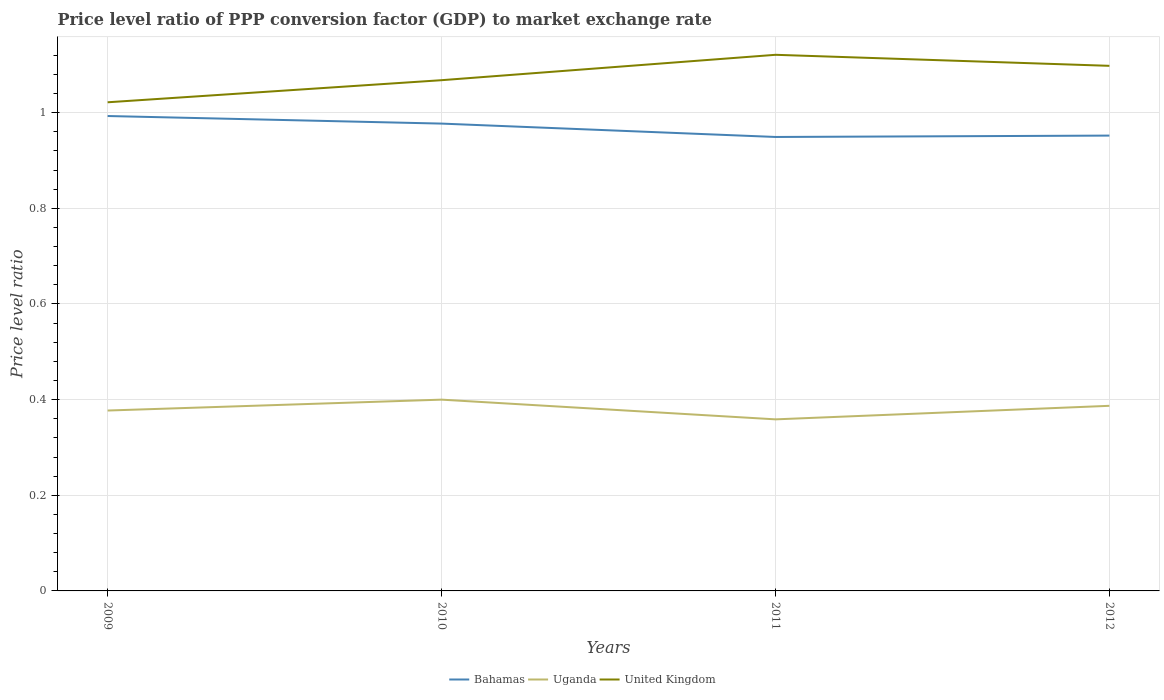How many different coloured lines are there?
Provide a succinct answer. 3. Does the line corresponding to Bahamas intersect with the line corresponding to United Kingdom?
Ensure brevity in your answer.  No. Across all years, what is the maximum price level ratio in Bahamas?
Give a very brief answer. 0.95. In which year was the price level ratio in United Kingdom maximum?
Ensure brevity in your answer.  2009. What is the total price level ratio in Uganda in the graph?
Keep it short and to the point. -0.03. What is the difference between the highest and the second highest price level ratio in Uganda?
Your answer should be compact. 0.04. What is the difference between the highest and the lowest price level ratio in United Kingdom?
Your response must be concise. 2. Is the price level ratio in United Kingdom strictly greater than the price level ratio in Bahamas over the years?
Offer a terse response. No. What is the difference between two consecutive major ticks on the Y-axis?
Keep it short and to the point. 0.2. Are the values on the major ticks of Y-axis written in scientific E-notation?
Offer a terse response. No. Does the graph contain any zero values?
Provide a short and direct response. No. Does the graph contain grids?
Keep it short and to the point. Yes. Where does the legend appear in the graph?
Your answer should be very brief. Bottom center. How many legend labels are there?
Provide a succinct answer. 3. How are the legend labels stacked?
Give a very brief answer. Horizontal. What is the title of the graph?
Give a very brief answer. Price level ratio of PPP conversion factor (GDP) to market exchange rate. What is the label or title of the X-axis?
Give a very brief answer. Years. What is the label or title of the Y-axis?
Give a very brief answer. Price level ratio. What is the Price level ratio of Bahamas in 2009?
Make the answer very short. 0.99. What is the Price level ratio in Uganda in 2009?
Your answer should be very brief. 0.38. What is the Price level ratio of United Kingdom in 2009?
Ensure brevity in your answer.  1.02. What is the Price level ratio of Bahamas in 2010?
Provide a short and direct response. 0.98. What is the Price level ratio of Uganda in 2010?
Make the answer very short. 0.4. What is the Price level ratio in United Kingdom in 2010?
Provide a short and direct response. 1.07. What is the Price level ratio in Bahamas in 2011?
Ensure brevity in your answer.  0.95. What is the Price level ratio of Uganda in 2011?
Your response must be concise. 0.36. What is the Price level ratio in United Kingdom in 2011?
Your response must be concise. 1.12. What is the Price level ratio of Bahamas in 2012?
Keep it short and to the point. 0.95. What is the Price level ratio of Uganda in 2012?
Offer a terse response. 0.39. What is the Price level ratio of United Kingdom in 2012?
Make the answer very short. 1.1. Across all years, what is the maximum Price level ratio of Bahamas?
Ensure brevity in your answer.  0.99. Across all years, what is the maximum Price level ratio of Uganda?
Give a very brief answer. 0.4. Across all years, what is the maximum Price level ratio of United Kingdom?
Make the answer very short. 1.12. Across all years, what is the minimum Price level ratio of Bahamas?
Your response must be concise. 0.95. Across all years, what is the minimum Price level ratio of Uganda?
Give a very brief answer. 0.36. Across all years, what is the minimum Price level ratio in United Kingdom?
Ensure brevity in your answer.  1.02. What is the total Price level ratio in Bahamas in the graph?
Your answer should be compact. 3.87. What is the total Price level ratio of Uganda in the graph?
Your answer should be compact. 1.52. What is the total Price level ratio of United Kingdom in the graph?
Make the answer very short. 4.31. What is the difference between the Price level ratio of Bahamas in 2009 and that in 2010?
Give a very brief answer. 0.02. What is the difference between the Price level ratio of Uganda in 2009 and that in 2010?
Provide a succinct answer. -0.02. What is the difference between the Price level ratio of United Kingdom in 2009 and that in 2010?
Give a very brief answer. -0.05. What is the difference between the Price level ratio of Bahamas in 2009 and that in 2011?
Offer a very short reply. 0.04. What is the difference between the Price level ratio in Uganda in 2009 and that in 2011?
Ensure brevity in your answer.  0.02. What is the difference between the Price level ratio of United Kingdom in 2009 and that in 2011?
Provide a succinct answer. -0.1. What is the difference between the Price level ratio of Bahamas in 2009 and that in 2012?
Keep it short and to the point. 0.04. What is the difference between the Price level ratio in Uganda in 2009 and that in 2012?
Your response must be concise. -0.01. What is the difference between the Price level ratio in United Kingdom in 2009 and that in 2012?
Offer a terse response. -0.08. What is the difference between the Price level ratio of Bahamas in 2010 and that in 2011?
Ensure brevity in your answer.  0.03. What is the difference between the Price level ratio of Uganda in 2010 and that in 2011?
Your answer should be compact. 0.04. What is the difference between the Price level ratio of United Kingdom in 2010 and that in 2011?
Provide a succinct answer. -0.05. What is the difference between the Price level ratio of Bahamas in 2010 and that in 2012?
Provide a short and direct response. 0.03. What is the difference between the Price level ratio in Uganda in 2010 and that in 2012?
Make the answer very short. 0.01. What is the difference between the Price level ratio in United Kingdom in 2010 and that in 2012?
Make the answer very short. -0.03. What is the difference between the Price level ratio in Bahamas in 2011 and that in 2012?
Your response must be concise. -0. What is the difference between the Price level ratio in Uganda in 2011 and that in 2012?
Give a very brief answer. -0.03. What is the difference between the Price level ratio in United Kingdom in 2011 and that in 2012?
Your answer should be compact. 0.02. What is the difference between the Price level ratio of Bahamas in 2009 and the Price level ratio of Uganda in 2010?
Ensure brevity in your answer.  0.59. What is the difference between the Price level ratio in Bahamas in 2009 and the Price level ratio in United Kingdom in 2010?
Provide a short and direct response. -0.07. What is the difference between the Price level ratio of Uganda in 2009 and the Price level ratio of United Kingdom in 2010?
Offer a terse response. -0.69. What is the difference between the Price level ratio in Bahamas in 2009 and the Price level ratio in Uganda in 2011?
Provide a succinct answer. 0.63. What is the difference between the Price level ratio of Bahamas in 2009 and the Price level ratio of United Kingdom in 2011?
Offer a very short reply. -0.13. What is the difference between the Price level ratio in Uganda in 2009 and the Price level ratio in United Kingdom in 2011?
Offer a very short reply. -0.74. What is the difference between the Price level ratio of Bahamas in 2009 and the Price level ratio of Uganda in 2012?
Offer a very short reply. 0.61. What is the difference between the Price level ratio in Bahamas in 2009 and the Price level ratio in United Kingdom in 2012?
Your answer should be compact. -0.1. What is the difference between the Price level ratio in Uganda in 2009 and the Price level ratio in United Kingdom in 2012?
Provide a succinct answer. -0.72. What is the difference between the Price level ratio of Bahamas in 2010 and the Price level ratio of Uganda in 2011?
Keep it short and to the point. 0.62. What is the difference between the Price level ratio in Bahamas in 2010 and the Price level ratio in United Kingdom in 2011?
Make the answer very short. -0.14. What is the difference between the Price level ratio in Uganda in 2010 and the Price level ratio in United Kingdom in 2011?
Provide a succinct answer. -0.72. What is the difference between the Price level ratio in Bahamas in 2010 and the Price level ratio in Uganda in 2012?
Your response must be concise. 0.59. What is the difference between the Price level ratio in Bahamas in 2010 and the Price level ratio in United Kingdom in 2012?
Give a very brief answer. -0.12. What is the difference between the Price level ratio of Uganda in 2010 and the Price level ratio of United Kingdom in 2012?
Your answer should be compact. -0.7. What is the difference between the Price level ratio in Bahamas in 2011 and the Price level ratio in Uganda in 2012?
Your answer should be very brief. 0.56. What is the difference between the Price level ratio in Bahamas in 2011 and the Price level ratio in United Kingdom in 2012?
Offer a terse response. -0.15. What is the difference between the Price level ratio of Uganda in 2011 and the Price level ratio of United Kingdom in 2012?
Keep it short and to the point. -0.74. What is the average Price level ratio in Bahamas per year?
Make the answer very short. 0.97. What is the average Price level ratio of Uganda per year?
Provide a short and direct response. 0.38. What is the average Price level ratio in United Kingdom per year?
Provide a succinct answer. 1.08. In the year 2009, what is the difference between the Price level ratio of Bahamas and Price level ratio of Uganda?
Offer a very short reply. 0.62. In the year 2009, what is the difference between the Price level ratio of Bahamas and Price level ratio of United Kingdom?
Keep it short and to the point. -0.03. In the year 2009, what is the difference between the Price level ratio of Uganda and Price level ratio of United Kingdom?
Your response must be concise. -0.64. In the year 2010, what is the difference between the Price level ratio of Bahamas and Price level ratio of Uganda?
Provide a short and direct response. 0.58. In the year 2010, what is the difference between the Price level ratio in Bahamas and Price level ratio in United Kingdom?
Your answer should be very brief. -0.09. In the year 2010, what is the difference between the Price level ratio of Uganda and Price level ratio of United Kingdom?
Provide a short and direct response. -0.67. In the year 2011, what is the difference between the Price level ratio of Bahamas and Price level ratio of Uganda?
Your response must be concise. 0.59. In the year 2011, what is the difference between the Price level ratio of Bahamas and Price level ratio of United Kingdom?
Offer a terse response. -0.17. In the year 2011, what is the difference between the Price level ratio in Uganda and Price level ratio in United Kingdom?
Offer a very short reply. -0.76. In the year 2012, what is the difference between the Price level ratio of Bahamas and Price level ratio of Uganda?
Offer a terse response. 0.56. In the year 2012, what is the difference between the Price level ratio of Bahamas and Price level ratio of United Kingdom?
Give a very brief answer. -0.15. In the year 2012, what is the difference between the Price level ratio of Uganda and Price level ratio of United Kingdom?
Offer a very short reply. -0.71. What is the ratio of the Price level ratio in Bahamas in 2009 to that in 2010?
Your answer should be compact. 1.02. What is the ratio of the Price level ratio in Uganda in 2009 to that in 2010?
Provide a succinct answer. 0.94. What is the ratio of the Price level ratio of United Kingdom in 2009 to that in 2010?
Ensure brevity in your answer.  0.96. What is the ratio of the Price level ratio in Bahamas in 2009 to that in 2011?
Offer a terse response. 1.05. What is the ratio of the Price level ratio of Uganda in 2009 to that in 2011?
Make the answer very short. 1.05. What is the ratio of the Price level ratio in United Kingdom in 2009 to that in 2011?
Ensure brevity in your answer.  0.91. What is the ratio of the Price level ratio in Bahamas in 2009 to that in 2012?
Provide a succinct answer. 1.04. What is the ratio of the Price level ratio of Uganda in 2009 to that in 2012?
Your response must be concise. 0.97. What is the ratio of the Price level ratio of United Kingdom in 2009 to that in 2012?
Offer a very short reply. 0.93. What is the ratio of the Price level ratio in Bahamas in 2010 to that in 2011?
Offer a very short reply. 1.03. What is the ratio of the Price level ratio in Uganda in 2010 to that in 2011?
Ensure brevity in your answer.  1.11. What is the ratio of the Price level ratio in United Kingdom in 2010 to that in 2011?
Ensure brevity in your answer.  0.95. What is the ratio of the Price level ratio in Bahamas in 2010 to that in 2012?
Give a very brief answer. 1.03. What is the ratio of the Price level ratio of United Kingdom in 2010 to that in 2012?
Provide a succinct answer. 0.97. What is the ratio of the Price level ratio of Uganda in 2011 to that in 2012?
Offer a very short reply. 0.93. What is the difference between the highest and the second highest Price level ratio of Bahamas?
Keep it short and to the point. 0.02. What is the difference between the highest and the second highest Price level ratio in Uganda?
Your response must be concise. 0.01. What is the difference between the highest and the second highest Price level ratio of United Kingdom?
Your answer should be very brief. 0.02. What is the difference between the highest and the lowest Price level ratio of Bahamas?
Offer a terse response. 0.04. What is the difference between the highest and the lowest Price level ratio in Uganda?
Provide a short and direct response. 0.04. What is the difference between the highest and the lowest Price level ratio of United Kingdom?
Provide a short and direct response. 0.1. 